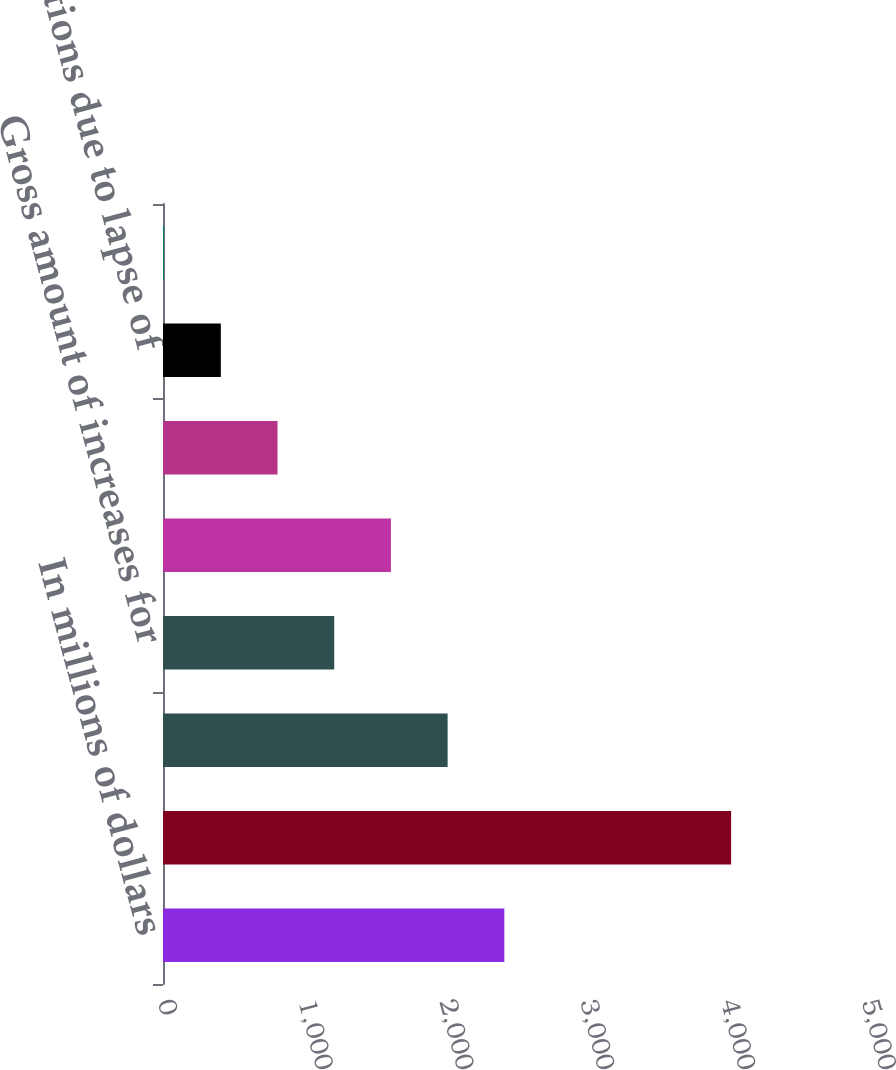Convert chart. <chart><loc_0><loc_0><loc_500><loc_500><bar_chart><fcel>In millions of dollars<fcel>Total unrecognized tax<fcel>Net amount of increases for<fcel>Gross amount of increases for<fcel>Gross amount of decreases for<fcel>Amounts of decreases relating<fcel>Reductions due to lapse of<fcel>Foreign exchange acquisitions<nl><fcel>2424.2<fcel>4035<fcel>2021.5<fcel>1216.1<fcel>1618.8<fcel>813.4<fcel>410.7<fcel>8<nl></chart> 